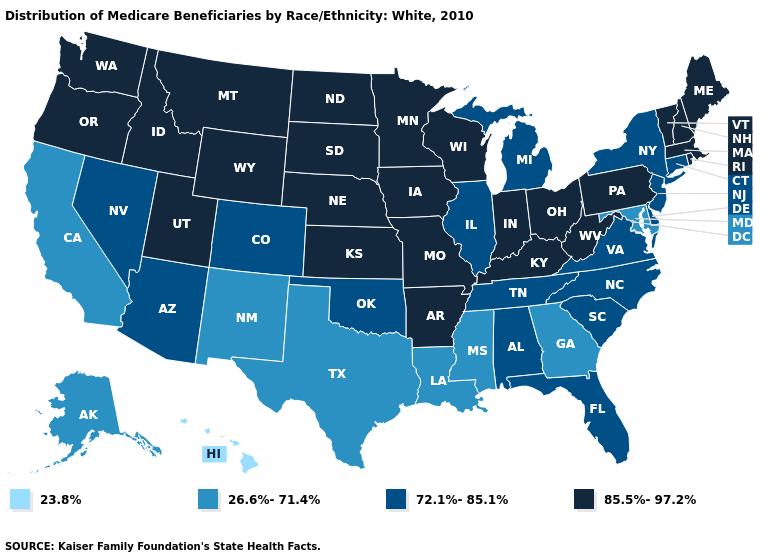Does Nevada have the highest value in the West?
Give a very brief answer. No. What is the value of New York?
Quick response, please. 72.1%-85.1%. What is the value of Delaware?
Answer briefly. 72.1%-85.1%. Name the states that have a value in the range 23.8%?
Concise answer only. Hawaii. What is the highest value in the South ?
Concise answer only. 85.5%-97.2%. Name the states that have a value in the range 23.8%?
Answer briefly. Hawaii. What is the value of Colorado?
Be succinct. 72.1%-85.1%. What is the value of Kentucky?
Quick response, please. 85.5%-97.2%. How many symbols are there in the legend?
Be succinct. 4. Name the states that have a value in the range 23.8%?
Quick response, please. Hawaii. What is the highest value in the South ?
Answer briefly. 85.5%-97.2%. What is the value of South Carolina?
Short answer required. 72.1%-85.1%. What is the value of Nebraska?
Keep it brief. 85.5%-97.2%. Does Mississippi have the highest value in the USA?
Answer briefly. No. Which states have the lowest value in the USA?
Quick response, please. Hawaii. 